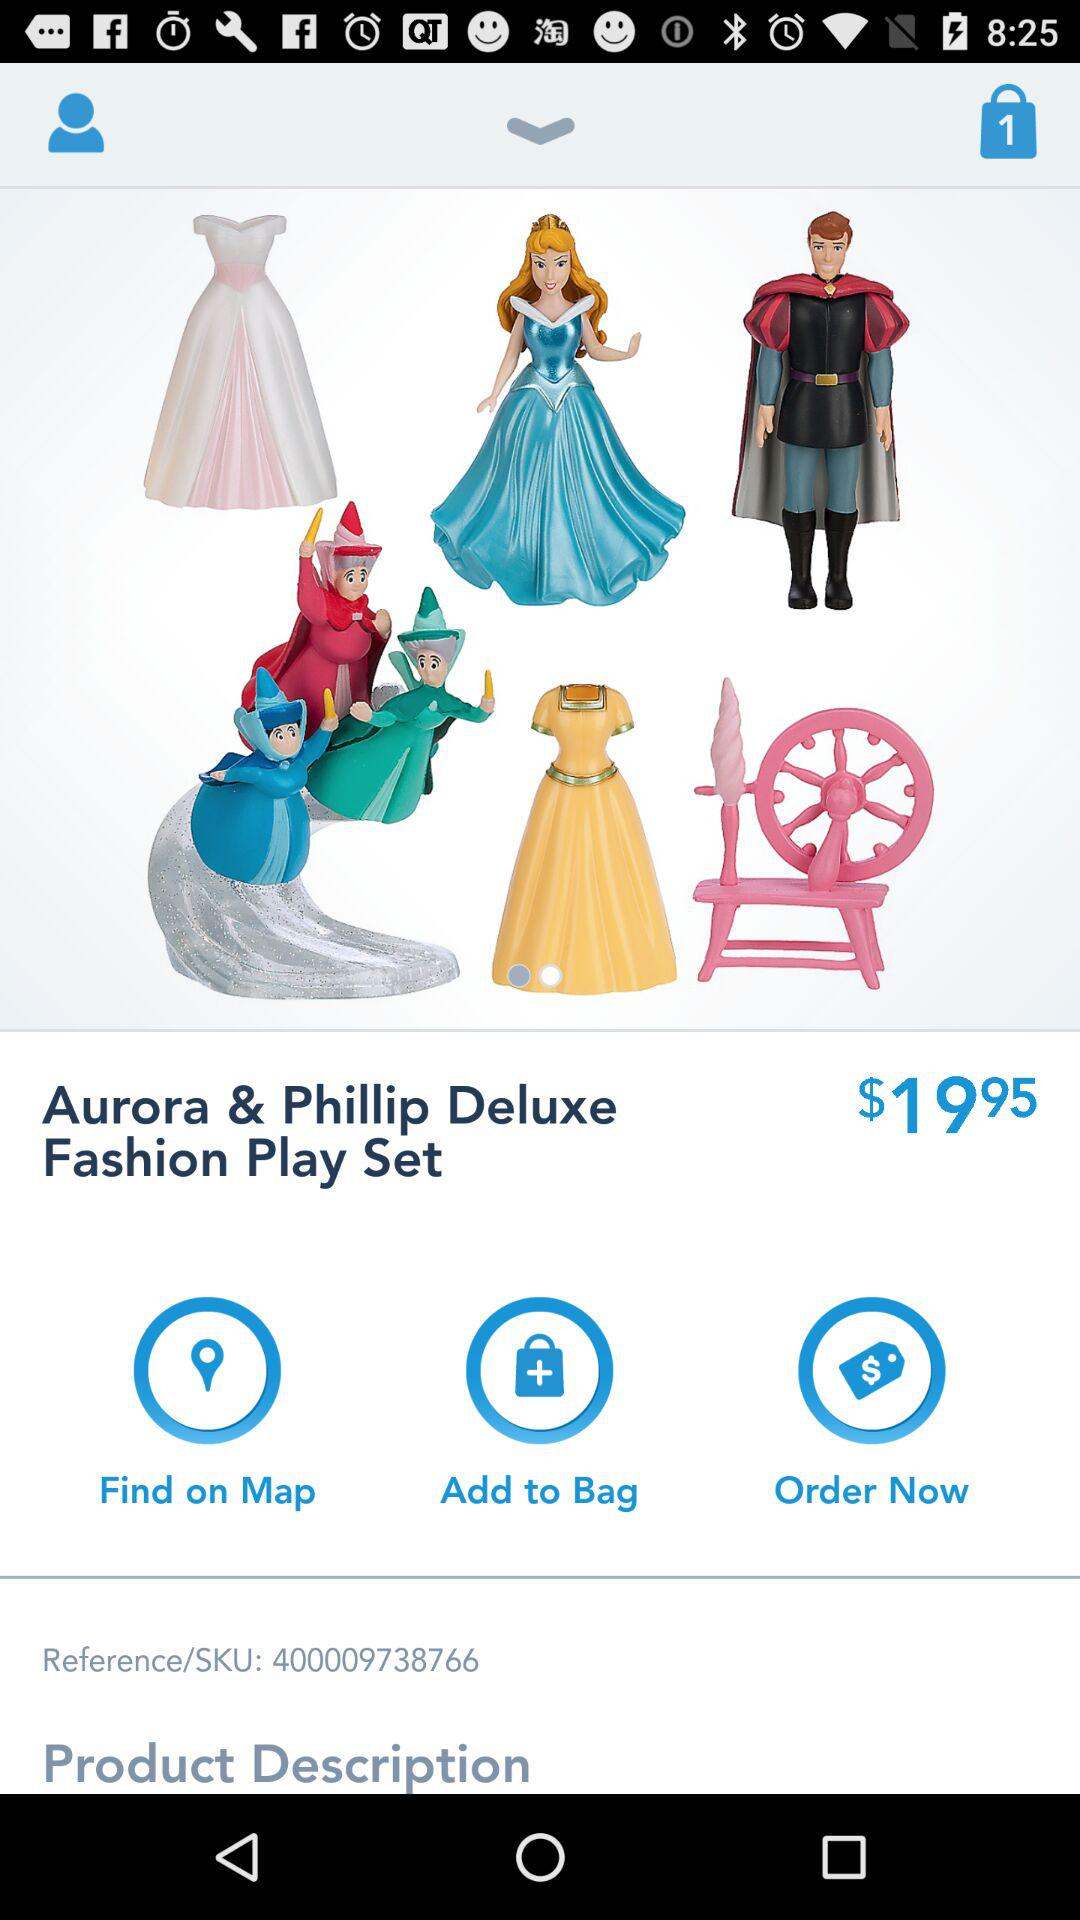What's the reference/SKU number? The reference/SKU number is 400009738766. 